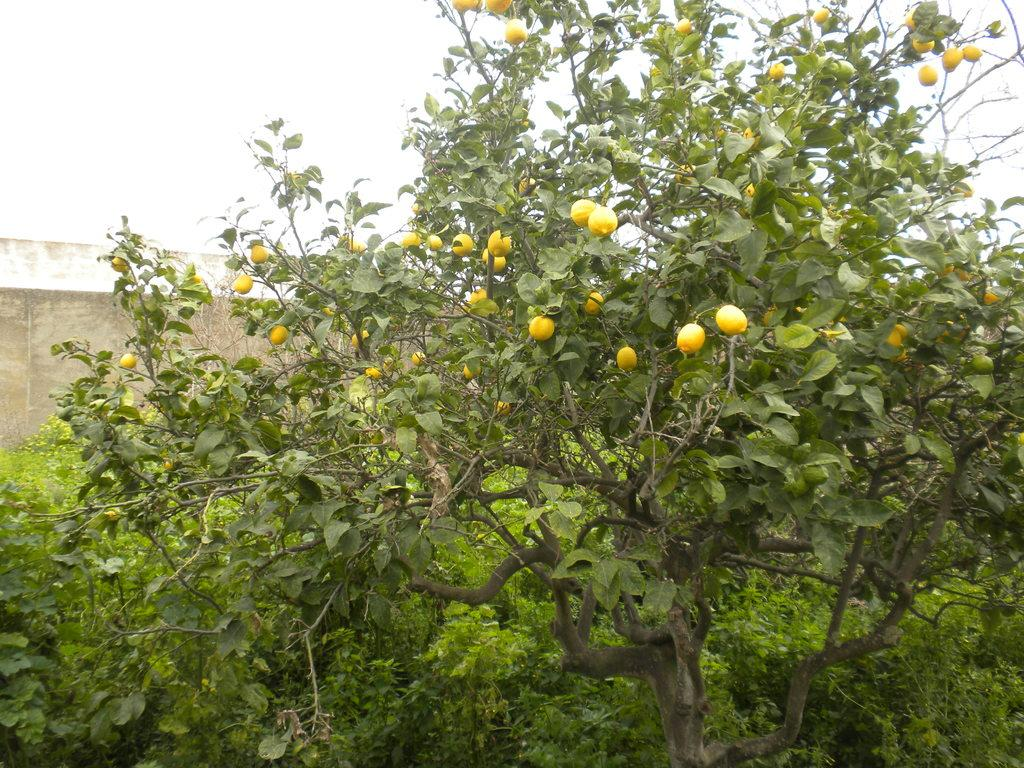What type of plant is featured prominently in the image? There is a tree with fruits in the image. Are there any other plants visible in the image? Yes, there are other trees in the image. What can be seen in the background of the image? There is a wall and the sky visible in the background of the image. What type of industry can be seen in the background of the image? There is no industry visible in the background of the image; it features a wall and the sky. What type of stone is used to build the wall in the image? The image does not provide enough detail to determine the type of stone used to build the wall. 